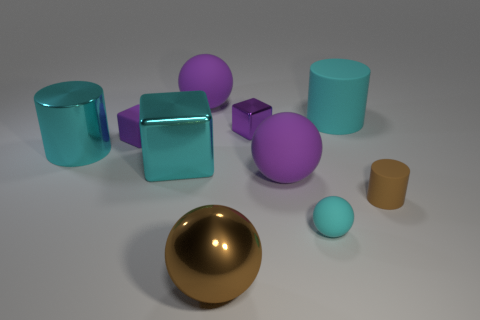Subtract all tiny rubber cubes. How many cubes are left? 2 Subtract all cylinders. How many objects are left? 7 Subtract all cyan blocks. How many blocks are left? 2 Subtract all blue blocks. Subtract all cyan cylinders. How many blocks are left? 3 Subtract all green balls. How many brown cubes are left? 0 Subtract all small cyan rubber balls. Subtract all cyan cubes. How many objects are left? 8 Add 3 purple shiny things. How many purple shiny things are left? 4 Add 7 tiny purple rubber blocks. How many tiny purple rubber blocks exist? 8 Subtract 1 brown cylinders. How many objects are left? 9 Subtract 3 balls. How many balls are left? 1 